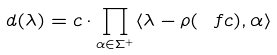Convert formula to latex. <formula><loc_0><loc_0><loc_500><loc_500>d ( \lambda ) = c \cdot \prod _ { \alpha \in \Sigma ^ { + } } \langle \lambda - \rho ( \ f c ) , \alpha \rangle</formula> 